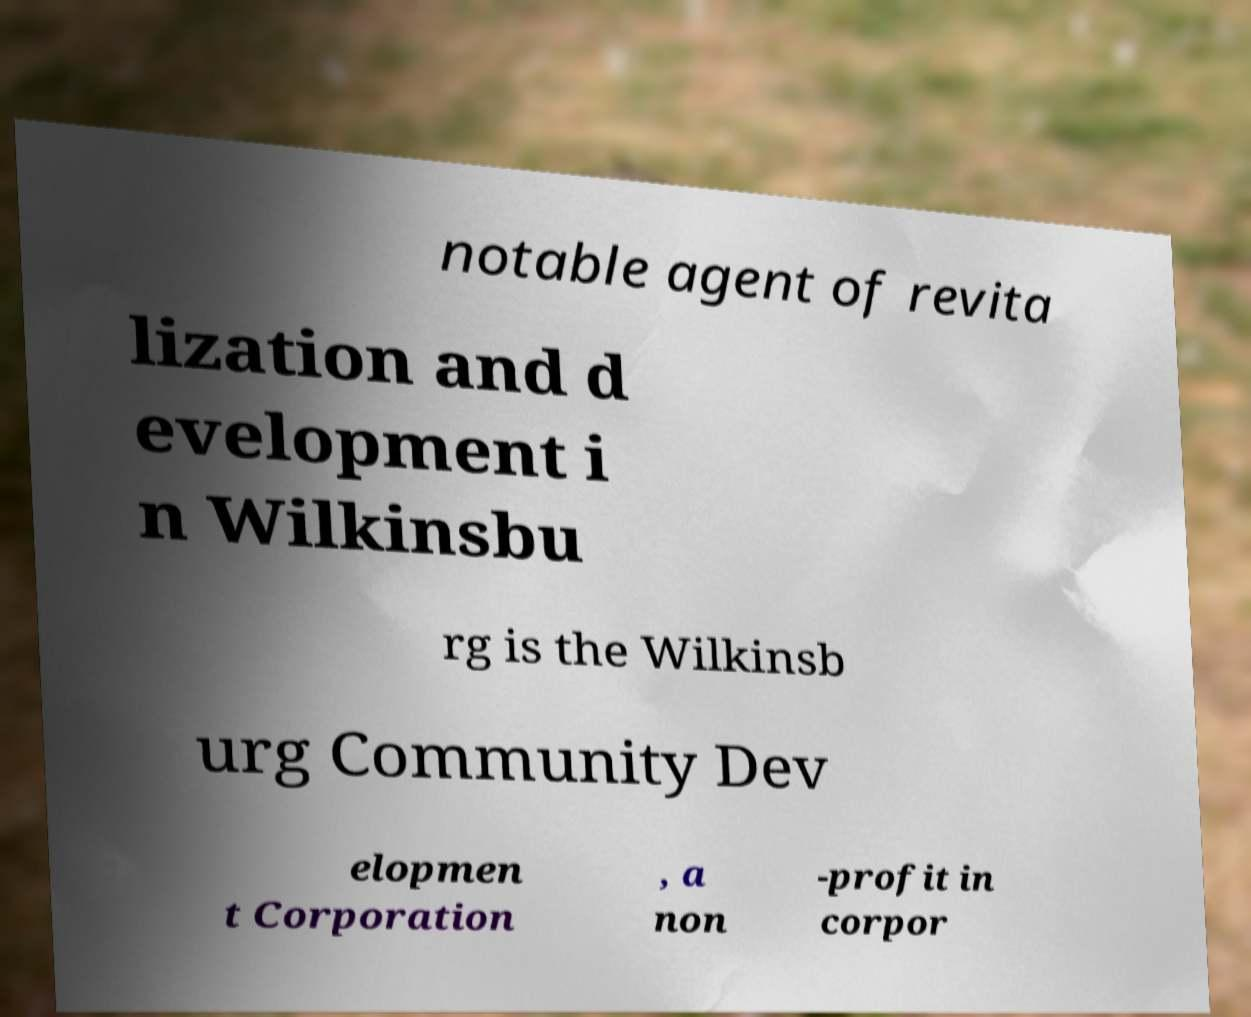Please read and relay the text visible in this image. What does it say? notable agent of revita lization and d evelopment i n Wilkinsbu rg is the Wilkinsb urg Community Dev elopmen t Corporation , a non -profit in corpor 